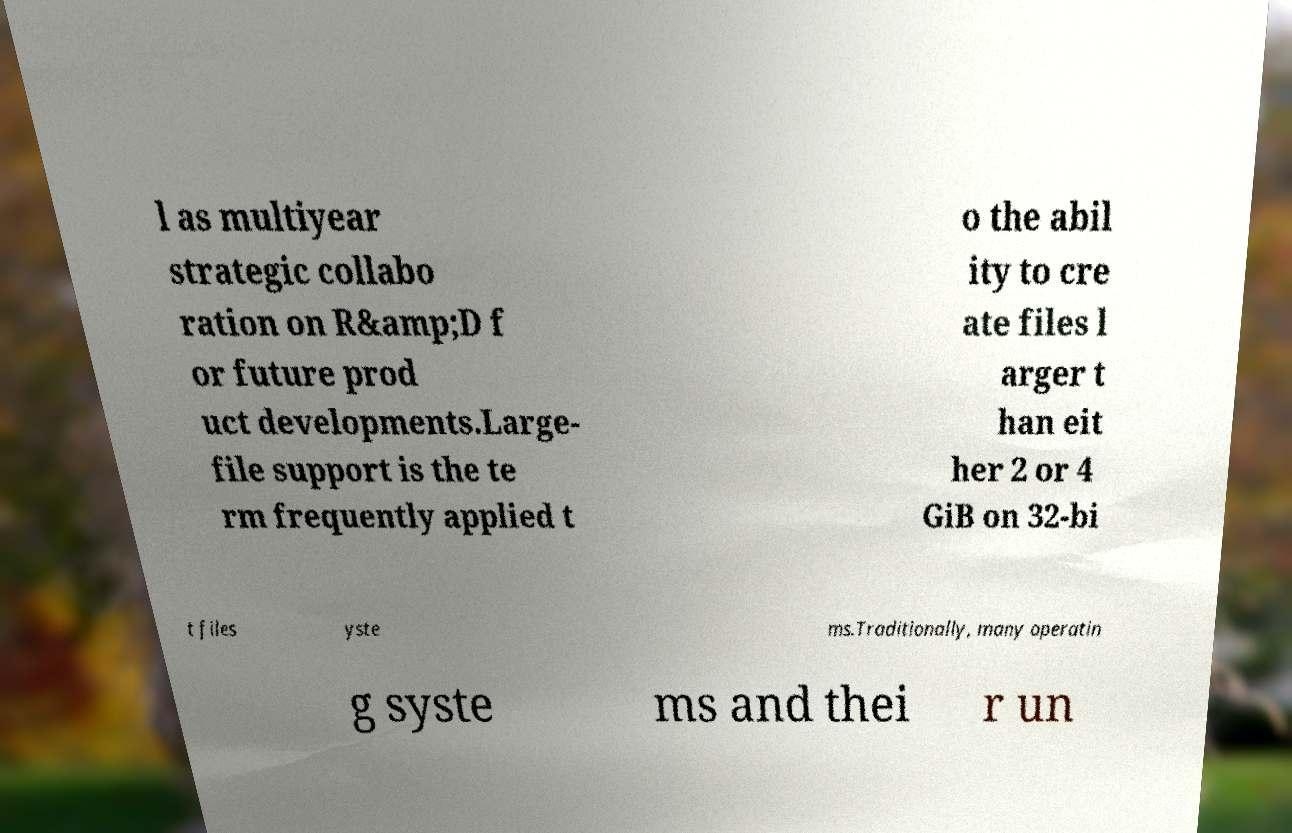For documentation purposes, I need the text within this image transcribed. Could you provide that? l as multiyear strategic collabo ration on R&amp;D f or future prod uct developments.Large- file support is the te rm frequently applied t o the abil ity to cre ate files l arger t han eit her 2 or 4 GiB on 32-bi t files yste ms.Traditionally, many operatin g syste ms and thei r un 